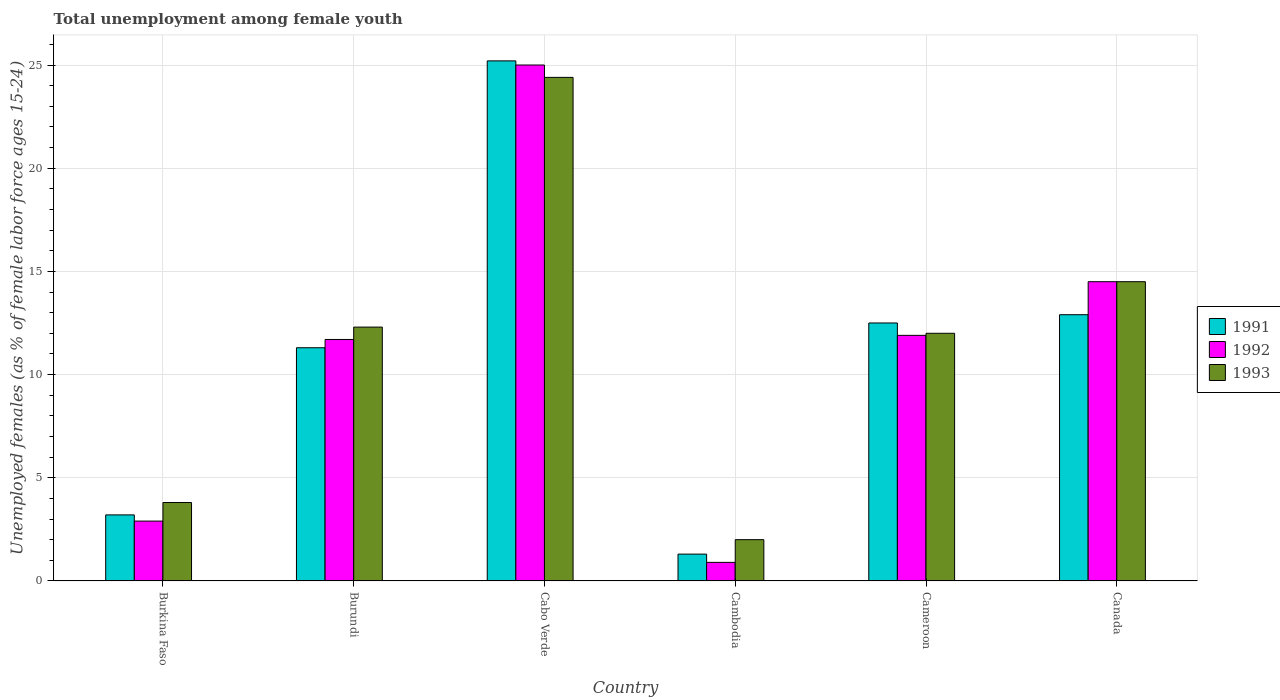Are the number of bars per tick equal to the number of legend labels?
Give a very brief answer. Yes. Are the number of bars on each tick of the X-axis equal?
Offer a very short reply. Yes. How many bars are there on the 2nd tick from the left?
Provide a short and direct response. 3. How many bars are there on the 3rd tick from the right?
Ensure brevity in your answer.  3. What is the label of the 3rd group of bars from the left?
Keep it short and to the point. Cabo Verde. In how many cases, is the number of bars for a given country not equal to the number of legend labels?
Offer a terse response. 0. What is the percentage of unemployed females in in 1992 in Cambodia?
Offer a terse response. 0.9. Across all countries, what is the maximum percentage of unemployed females in in 1993?
Make the answer very short. 24.4. In which country was the percentage of unemployed females in in 1991 maximum?
Keep it short and to the point. Cabo Verde. In which country was the percentage of unemployed females in in 1991 minimum?
Make the answer very short. Cambodia. What is the total percentage of unemployed females in in 1992 in the graph?
Ensure brevity in your answer.  66.9. What is the difference between the percentage of unemployed females in in 1993 in Cabo Verde and that in Canada?
Make the answer very short. 9.9. What is the difference between the percentage of unemployed females in in 1993 in Cabo Verde and the percentage of unemployed females in in 1992 in Burkina Faso?
Provide a succinct answer. 21.5. What is the average percentage of unemployed females in in 1991 per country?
Your answer should be compact. 11.07. What is the difference between the percentage of unemployed females in of/in 1992 and percentage of unemployed females in of/in 1993 in Burkina Faso?
Ensure brevity in your answer.  -0.9. What is the ratio of the percentage of unemployed females in in 1993 in Burkina Faso to that in Canada?
Your answer should be compact. 0.26. Is the percentage of unemployed females in in 1992 in Burundi less than that in Cameroon?
Make the answer very short. Yes. What is the difference between the highest and the second highest percentage of unemployed females in in 1991?
Keep it short and to the point. 12.3. What is the difference between the highest and the lowest percentage of unemployed females in in 1993?
Offer a very short reply. 22.4. Is the sum of the percentage of unemployed females in in 1991 in Burkina Faso and Cambodia greater than the maximum percentage of unemployed females in in 1993 across all countries?
Your answer should be very brief. No. What does the 2nd bar from the left in Cambodia represents?
Make the answer very short. 1992. Is it the case that in every country, the sum of the percentage of unemployed females in in 1992 and percentage of unemployed females in in 1991 is greater than the percentage of unemployed females in in 1993?
Your response must be concise. Yes. Are all the bars in the graph horizontal?
Offer a very short reply. No. Are the values on the major ticks of Y-axis written in scientific E-notation?
Make the answer very short. No. Does the graph contain any zero values?
Give a very brief answer. No. Where does the legend appear in the graph?
Provide a succinct answer. Center right. How many legend labels are there?
Offer a very short reply. 3. How are the legend labels stacked?
Provide a short and direct response. Vertical. What is the title of the graph?
Your answer should be compact. Total unemployment among female youth. Does "2012" appear as one of the legend labels in the graph?
Give a very brief answer. No. What is the label or title of the Y-axis?
Provide a short and direct response. Unemployed females (as % of female labor force ages 15-24). What is the Unemployed females (as % of female labor force ages 15-24) in 1991 in Burkina Faso?
Ensure brevity in your answer.  3.2. What is the Unemployed females (as % of female labor force ages 15-24) of 1992 in Burkina Faso?
Your response must be concise. 2.9. What is the Unemployed females (as % of female labor force ages 15-24) of 1993 in Burkina Faso?
Provide a short and direct response. 3.8. What is the Unemployed females (as % of female labor force ages 15-24) in 1991 in Burundi?
Make the answer very short. 11.3. What is the Unemployed females (as % of female labor force ages 15-24) in 1992 in Burundi?
Ensure brevity in your answer.  11.7. What is the Unemployed females (as % of female labor force ages 15-24) in 1993 in Burundi?
Provide a short and direct response. 12.3. What is the Unemployed females (as % of female labor force ages 15-24) in 1991 in Cabo Verde?
Your answer should be very brief. 25.2. What is the Unemployed females (as % of female labor force ages 15-24) of 1993 in Cabo Verde?
Your answer should be compact. 24.4. What is the Unemployed females (as % of female labor force ages 15-24) in 1991 in Cambodia?
Your response must be concise. 1.3. What is the Unemployed females (as % of female labor force ages 15-24) of 1992 in Cambodia?
Offer a very short reply. 0.9. What is the Unemployed females (as % of female labor force ages 15-24) in 1993 in Cambodia?
Make the answer very short. 2. What is the Unemployed females (as % of female labor force ages 15-24) of 1992 in Cameroon?
Your answer should be very brief. 11.9. What is the Unemployed females (as % of female labor force ages 15-24) of 1991 in Canada?
Provide a succinct answer. 12.9. What is the Unemployed females (as % of female labor force ages 15-24) in 1992 in Canada?
Provide a short and direct response. 14.5. What is the Unemployed females (as % of female labor force ages 15-24) in 1993 in Canada?
Offer a terse response. 14.5. Across all countries, what is the maximum Unemployed females (as % of female labor force ages 15-24) in 1991?
Provide a succinct answer. 25.2. Across all countries, what is the maximum Unemployed females (as % of female labor force ages 15-24) of 1992?
Your answer should be very brief. 25. Across all countries, what is the maximum Unemployed females (as % of female labor force ages 15-24) of 1993?
Provide a short and direct response. 24.4. Across all countries, what is the minimum Unemployed females (as % of female labor force ages 15-24) of 1991?
Offer a terse response. 1.3. Across all countries, what is the minimum Unemployed females (as % of female labor force ages 15-24) in 1992?
Offer a very short reply. 0.9. What is the total Unemployed females (as % of female labor force ages 15-24) of 1991 in the graph?
Give a very brief answer. 66.4. What is the total Unemployed females (as % of female labor force ages 15-24) in 1992 in the graph?
Provide a short and direct response. 66.9. What is the total Unemployed females (as % of female labor force ages 15-24) of 1993 in the graph?
Provide a succinct answer. 69. What is the difference between the Unemployed females (as % of female labor force ages 15-24) of 1993 in Burkina Faso and that in Burundi?
Your response must be concise. -8.5. What is the difference between the Unemployed females (as % of female labor force ages 15-24) of 1992 in Burkina Faso and that in Cabo Verde?
Provide a succinct answer. -22.1. What is the difference between the Unemployed females (as % of female labor force ages 15-24) in 1993 in Burkina Faso and that in Cabo Verde?
Offer a terse response. -20.6. What is the difference between the Unemployed females (as % of female labor force ages 15-24) of 1991 in Burkina Faso and that in Cambodia?
Offer a terse response. 1.9. What is the difference between the Unemployed females (as % of female labor force ages 15-24) in 1993 in Burkina Faso and that in Cambodia?
Your answer should be compact. 1.8. What is the difference between the Unemployed females (as % of female labor force ages 15-24) of 1991 in Burkina Faso and that in Cameroon?
Make the answer very short. -9.3. What is the difference between the Unemployed females (as % of female labor force ages 15-24) in 1991 in Burkina Faso and that in Canada?
Your answer should be very brief. -9.7. What is the difference between the Unemployed females (as % of female labor force ages 15-24) of 1993 in Burkina Faso and that in Canada?
Keep it short and to the point. -10.7. What is the difference between the Unemployed females (as % of female labor force ages 15-24) in 1991 in Burundi and that in Cabo Verde?
Provide a short and direct response. -13.9. What is the difference between the Unemployed females (as % of female labor force ages 15-24) of 1992 in Burundi and that in Cabo Verde?
Provide a short and direct response. -13.3. What is the difference between the Unemployed females (as % of female labor force ages 15-24) of 1993 in Burundi and that in Canada?
Offer a terse response. -2.2. What is the difference between the Unemployed females (as % of female labor force ages 15-24) in 1991 in Cabo Verde and that in Cambodia?
Your answer should be very brief. 23.9. What is the difference between the Unemployed females (as % of female labor force ages 15-24) of 1992 in Cabo Verde and that in Cambodia?
Ensure brevity in your answer.  24.1. What is the difference between the Unemployed females (as % of female labor force ages 15-24) of 1993 in Cabo Verde and that in Cambodia?
Keep it short and to the point. 22.4. What is the difference between the Unemployed females (as % of female labor force ages 15-24) of 1991 in Cabo Verde and that in Cameroon?
Offer a very short reply. 12.7. What is the difference between the Unemployed females (as % of female labor force ages 15-24) in 1991 in Cabo Verde and that in Canada?
Ensure brevity in your answer.  12.3. What is the difference between the Unemployed females (as % of female labor force ages 15-24) in 1992 in Cabo Verde and that in Canada?
Offer a very short reply. 10.5. What is the difference between the Unemployed females (as % of female labor force ages 15-24) in 1991 in Cambodia and that in Cameroon?
Give a very brief answer. -11.2. What is the difference between the Unemployed females (as % of female labor force ages 15-24) of 1992 in Cambodia and that in Cameroon?
Your answer should be compact. -11. What is the difference between the Unemployed females (as % of female labor force ages 15-24) of 1991 in Cambodia and that in Canada?
Offer a very short reply. -11.6. What is the difference between the Unemployed females (as % of female labor force ages 15-24) in 1992 in Cambodia and that in Canada?
Give a very brief answer. -13.6. What is the difference between the Unemployed females (as % of female labor force ages 15-24) of 1993 in Cambodia and that in Canada?
Keep it short and to the point. -12.5. What is the difference between the Unemployed females (as % of female labor force ages 15-24) of 1991 in Cameroon and that in Canada?
Make the answer very short. -0.4. What is the difference between the Unemployed females (as % of female labor force ages 15-24) of 1992 in Cameroon and that in Canada?
Keep it short and to the point. -2.6. What is the difference between the Unemployed females (as % of female labor force ages 15-24) of 1993 in Cameroon and that in Canada?
Your response must be concise. -2.5. What is the difference between the Unemployed females (as % of female labor force ages 15-24) in 1991 in Burkina Faso and the Unemployed females (as % of female labor force ages 15-24) in 1992 in Burundi?
Your answer should be compact. -8.5. What is the difference between the Unemployed females (as % of female labor force ages 15-24) of 1991 in Burkina Faso and the Unemployed females (as % of female labor force ages 15-24) of 1992 in Cabo Verde?
Keep it short and to the point. -21.8. What is the difference between the Unemployed females (as % of female labor force ages 15-24) in 1991 in Burkina Faso and the Unemployed females (as % of female labor force ages 15-24) in 1993 in Cabo Verde?
Keep it short and to the point. -21.2. What is the difference between the Unemployed females (as % of female labor force ages 15-24) of 1992 in Burkina Faso and the Unemployed females (as % of female labor force ages 15-24) of 1993 in Cabo Verde?
Your answer should be very brief. -21.5. What is the difference between the Unemployed females (as % of female labor force ages 15-24) in 1991 in Burkina Faso and the Unemployed females (as % of female labor force ages 15-24) in 1992 in Cambodia?
Provide a succinct answer. 2.3. What is the difference between the Unemployed females (as % of female labor force ages 15-24) of 1991 in Burkina Faso and the Unemployed females (as % of female labor force ages 15-24) of 1993 in Cambodia?
Ensure brevity in your answer.  1.2. What is the difference between the Unemployed females (as % of female labor force ages 15-24) of 1991 in Burkina Faso and the Unemployed females (as % of female labor force ages 15-24) of 1993 in Cameroon?
Your response must be concise. -8.8. What is the difference between the Unemployed females (as % of female labor force ages 15-24) in 1991 in Burkina Faso and the Unemployed females (as % of female labor force ages 15-24) in 1992 in Canada?
Make the answer very short. -11.3. What is the difference between the Unemployed females (as % of female labor force ages 15-24) in 1991 in Burkina Faso and the Unemployed females (as % of female labor force ages 15-24) in 1993 in Canada?
Your answer should be compact. -11.3. What is the difference between the Unemployed females (as % of female labor force ages 15-24) in 1991 in Burundi and the Unemployed females (as % of female labor force ages 15-24) in 1992 in Cabo Verde?
Provide a short and direct response. -13.7. What is the difference between the Unemployed females (as % of female labor force ages 15-24) in 1991 in Burundi and the Unemployed females (as % of female labor force ages 15-24) in 1993 in Cabo Verde?
Keep it short and to the point. -13.1. What is the difference between the Unemployed females (as % of female labor force ages 15-24) in 1992 in Burundi and the Unemployed females (as % of female labor force ages 15-24) in 1993 in Cabo Verde?
Provide a short and direct response. -12.7. What is the difference between the Unemployed females (as % of female labor force ages 15-24) of 1991 in Burundi and the Unemployed females (as % of female labor force ages 15-24) of 1992 in Cambodia?
Keep it short and to the point. 10.4. What is the difference between the Unemployed females (as % of female labor force ages 15-24) of 1992 in Burundi and the Unemployed females (as % of female labor force ages 15-24) of 1993 in Cambodia?
Your response must be concise. 9.7. What is the difference between the Unemployed females (as % of female labor force ages 15-24) in 1991 in Burundi and the Unemployed females (as % of female labor force ages 15-24) in 1993 in Cameroon?
Offer a terse response. -0.7. What is the difference between the Unemployed females (as % of female labor force ages 15-24) in 1991 in Burundi and the Unemployed females (as % of female labor force ages 15-24) in 1992 in Canada?
Your answer should be compact. -3.2. What is the difference between the Unemployed females (as % of female labor force ages 15-24) of 1991 in Burundi and the Unemployed females (as % of female labor force ages 15-24) of 1993 in Canada?
Offer a very short reply. -3.2. What is the difference between the Unemployed females (as % of female labor force ages 15-24) in 1991 in Cabo Verde and the Unemployed females (as % of female labor force ages 15-24) in 1992 in Cambodia?
Your answer should be very brief. 24.3. What is the difference between the Unemployed females (as % of female labor force ages 15-24) in 1991 in Cabo Verde and the Unemployed females (as % of female labor force ages 15-24) in 1993 in Cambodia?
Your response must be concise. 23.2. What is the difference between the Unemployed females (as % of female labor force ages 15-24) of 1992 in Cabo Verde and the Unemployed females (as % of female labor force ages 15-24) of 1993 in Cambodia?
Provide a short and direct response. 23. What is the difference between the Unemployed females (as % of female labor force ages 15-24) of 1991 in Cabo Verde and the Unemployed females (as % of female labor force ages 15-24) of 1993 in Cameroon?
Offer a very short reply. 13.2. What is the difference between the Unemployed females (as % of female labor force ages 15-24) of 1992 in Cabo Verde and the Unemployed females (as % of female labor force ages 15-24) of 1993 in Cameroon?
Give a very brief answer. 13. What is the difference between the Unemployed females (as % of female labor force ages 15-24) in 1991 in Cabo Verde and the Unemployed females (as % of female labor force ages 15-24) in 1992 in Canada?
Ensure brevity in your answer.  10.7. What is the difference between the Unemployed females (as % of female labor force ages 15-24) of 1991 in Cambodia and the Unemployed females (as % of female labor force ages 15-24) of 1992 in Canada?
Ensure brevity in your answer.  -13.2. What is the difference between the Unemployed females (as % of female labor force ages 15-24) in 1992 in Cambodia and the Unemployed females (as % of female labor force ages 15-24) in 1993 in Canada?
Your response must be concise. -13.6. What is the difference between the Unemployed females (as % of female labor force ages 15-24) of 1991 in Cameroon and the Unemployed females (as % of female labor force ages 15-24) of 1993 in Canada?
Give a very brief answer. -2. What is the difference between the Unemployed females (as % of female labor force ages 15-24) in 1992 in Cameroon and the Unemployed females (as % of female labor force ages 15-24) in 1993 in Canada?
Your response must be concise. -2.6. What is the average Unemployed females (as % of female labor force ages 15-24) of 1991 per country?
Your response must be concise. 11.07. What is the average Unemployed females (as % of female labor force ages 15-24) of 1992 per country?
Your answer should be very brief. 11.15. What is the difference between the Unemployed females (as % of female labor force ages 15-24) of 1991 and Unemployed females (as % of female labor force ages 15-24) of 1992 in Burkina Faso?
Your response must be concise. 0.3. What is the difference between the Unemployed females (as % of female labor force ages 15-24) of 1991 and Unemployed females (as % of female labor force ages 15-24) of 1993 in Burkina Faso?
Your response must be concise. -0.6. What is the difference between the Unemployed females (as % of female labor force ages 15-24) in 1992 and Unemployed females (as % of female labor force ages 15-24) in 1993 in Burkina Faso?
Keep it short and to the point. -0.9. What is the difference between the Unemployed females (as % of female labor force ages 15-24) in 1991 and Unemployed females (as % of female labor force ages 15-24) in 1992 in Burundi?
Provide a short and direct response. -0.4. What is the difference between the Unemployed females (as % of female labor force ages 15-24) in 1991 and Unemployed females (as % of female labor force ages 15-24) in 1993 in Burundi?
Give a very brief answer. -1. What is the difference between the Unemployed females (as % of female labor force ages 15-24) of 1992 and Unemployed females (as % of female labor force ages 15-24) of 1993 in Burundi?
Provide a succinct answer. -0.6. What is the difference between the Unemployed females (as % of female labor force ages 15-24) of 1991 and Unemployed females (as % of female labor force ages 15-24) of 1992 in Cabo Verde?
Offer a very short reply. 0.2. What is the difference between the Unemployed females (as % of female labor force ages 15-24) in 1991 and Unemployed females (as % of female labor force ages 15-24) in 1992 in Cambodia?
Keep it short and to the point. 0.4. What is the difference between the Unemployed females (as % of female labor force ages 15-24) in 1991 and Unemployed females (as % of female labor force ages 15-24) in 1993 in Cambodia?
Offer a very short reply. -0.7. What is the difference between the Unemployed females (as % of female labor force ages 15-24) of 1991 and Unemployed females (as % of female labor force ages 15-24) of 1993 in Cameroon?
Make the answer very short. 0.5. What is the difference between the Unemployed females (as % of female labor force ages 15-24) in 1992 and Unemployed females (as % of female labor force ages 15-24) in 1993 in Cameroon?
Your answer should be compact. -0.1. What is the difference between the Unemployed females (as % of female labor force ages 15-24) in 1991 and Unemployed females (as % of female labor force ages 15-24) in 1993 in Canada?
Offer a terse response. -1.6. What is the difference between the Unemployed females (as % of female labor force ages 15-24) in 1992 and Unemployed females (as % of female labor force ages 15-24) in 1993 in Canada?
Your answer should be compact. 0. What is the ratio of the Unemployed females (as % of female labor force ages 15-24) of 1991 in Burkina Faso to that in Burundi?
Offer a very short reply. 0.28. What is the ratio of the Unemployed females (as % of female labor force ages 15-24) of 1992 in Burkina Faso to that in Burundi?
Provide a short and direct response. 0.25. What is the ratio of the Unemployed females (as % of female labor force ages 15-24) of 1993 in Burkina Faso to that in Burundi?
Provide a short and direct response. 0.31. What is the ratio of the Unemployed females (as % of female labor force ages 15-24) of 1991 in Burkina Faso to that in Cabo Verde?
Make the answer very short. 0.13. What is the ratio of the Unemployed females (as % of female labor force ages 15-24) of 1992 in Burkina Faso to that in Cabo Verde?
Offer a terse response. 0.12. What is the ratio of the Unemployed females (as % of female labor force ages 15-24) of 1993 in Burkina Faso to that in Cabo Verde?
Make the answer very short. 0.16. What is the ratio of the Unemployed females (as % of female labor force ages 15-24) of 1991 in Burkina Faso to that in Cambodia?
Your answer should be very brief. 2.46. What is the ratio of the Unemployed females (as % of female labor force ages 15-24) in 1992 in Burkina Faso to that in Cambodia?
Your answer should be compact. 3.22. What is the ratio of the Unemployed females (as % of female labor force ages 15-24) in 1993 in Burkina Faso to that in Cambodia?
Provide a succinct answer. 1.9. What is the ratio of the Unemployed females (as % of female labor force ages 15-24) of 1991 in Burkina Faso to that in Cameroon?
Ensure brevity in your answer.  0.26. What is the ratio of the Unemployed females (as % of female labor force ages 15-24) of 1992 in Burkina Faso to that in Cameroon?
Ensure brevity in your answer.  0.24. What is the ratio of the Unemployed females (as % of female labor force ages 15-24) of 1993 in Burkina Faso to that in Cameroon?
Keep it short and to the point. 0.32. What is the ratio of the Unemployed females (as % of female labor force ages 15-24) of 1991 in Burkina Faso to that in Canada?
Keep it short and to the point. 0.25. What is the ratio of the Unemployed females (as % of female labor force ages 15-24) of 1993 in Burkina Faso to that in Canada?
Your answer should be compact. 0.26. What is the ratio of the Unemployed females (as % of female labor force ages 15-24) in 1991 in Burundi to that in Cabo Verde?
Ensure brevity in your answer.  0.45. What is the ratio of the Unemployed females (as % of female labor force ages 15-24) in 1992 in Burundi to that in Cabo Verde?
Provide a succinct answer. 0.47. What is the ratio of the Unemployed females (as % of female labor force ages 15-24) in 1993 in Burundi to that in Cabo Verde?
Your answer should be very brief. 0.5. What is the ratio of the Unemployed females (as % of female labor force ages 15-24) in 1991 in Burundi to that in Cambodia?
Provide a succinct answer. 8.69. What is the ratio of the Unemployed females (as % of female labor force ages 15-24) in 1992 in Burundi to that in Cambodia?
Provide a short and direct response. 13. What is the ratio of the Unemployed females (as % of female labor force ages 15-24) in 1993 in Burundi to that in Cambodia?
Provide a succinct answer. 6.15. What is the ratio of the Unemployed females (as % of female labor force ages 15-24) in 1991 in Burundi to that in Cameroon?
Provide a short and direct response. 0.9. What is the ratio of the Unemployed females (as % of female labor force ages 15-24) in 1992 in Burundi to that in Cameroon?
Your response must be concise. 0.98. What is the ratio of the Unemployed females (as % of female labor force ages 15-24) in 1991 in Burundi to that in Canada?
Provide a short and direct response. 0.88. What is the ratio of the Unemployed females (as % of female labor force ages 15-24) in 1992 in Burundi to that in Canada?
Offer a very short reply. 0.81. What is the ratio of the Unemployed females (as % of female labor force ages 15-24) of 1993 in Burundi to that in Canada?
Give a very brief answer. 0.85. What is the ratio of the Unemployed females (as % of female labor force ages 15-24) in 1991 in Cabo Verde to that in Cambodia?
Keep it short and to the point. 19.38. What is the ratio of the Unemployed females (as % of female labor force ages 15-24) of 1992 in Cabo Verde to that in Cambodia?
Ensure brevity in your answer.  27.78. What is the ratio of the Unemployed females (as % of female labor force ages 15-24) of 1991 in Cabo Verde to that in Cameroon?
Provide a succinct answer. 2.02. What is the ratio of the Unemployed females (as % of female labor force ages 15-24) of 1992 in Cabo Verde to that in Cameroon?
Give a very brief answer. 2.1. What is the ratio of the Unemployed females (as % of female labor force ages 15-24) in 1993 in Cabo Verde to that in Cameroon?
Your answer should be very brief. 2.03. What is the ratio of the Unemployed females (as % of female labor force ages 15-24) of 1991 in Cabo Verde to that in Canada?
Provide a short and direct response. 1.95. What is the ratio of the Unemployed females (as % of female labor force ages 15-24) in 1992 in Cabo Verde to that in Canada?
Provide a short and direct response. 1.72. What is the ratio of the Unemployed females (as % of female labor force ages 15-24) of 1993 in Cabo Verde to that in Canada?
Offer a very short reply. 1.68. What is the ratio of the Unemployed females (as % of female labor force ages 15-24) of 1991 in Cambodia to that in Cameroon?
Your answer should be very brief. 0.1. What is the ratio of the Unemployed females (as % of female labor force ages 15-24) in 1992 in Cambodia to that in Cameroon?
Ensure brevity in your answer.  0.08. What is the ratio of the Unemployed females (as % of female labor force ages 15-24) in 1991 in Cambodia to that in Canada?
Make the answer very short. 0.1. What is the ratio of the Unemployed females (as % of female labor force ages 15-24) in 1992 in Cambodia to that in Canada?
Your answer should be compact. 0.06. What is the ratio of the Unemployed females (as % of female labor force ages 15-24) in 1993 in Cambodia to that in Canada?
Offer a terse response. 0.14. What is the ratio of the Unemployed females (as % of female labor force ages 15-24) in 1991 in Cameroon to that in Canada?
Your answer should be compact. 0.97. What is the ratio of the Unemployed females (as % of female labor force ages 15-24) of 1992 in Cameroon to that in Canada?
Give a very brief answer. 0.82. What is the ratio of the Unemployed females (as % of female labor force ages 15-24) of 1993 in Cameroon to that in Canada?
Provide a short and direct response. 0.83. What is the difference between the highest and the second highest Unemployed females (as % of female labor force ages 15-24) of 1992?
Your response must be concise. 10.5. What is the difference between the highest and the second highest Unemployed females (as % of female labor force ages 15-24) of 1993?
Keep it short and to the point. 9.9. What is the difference between the highest and the lowest Unemployed females (as % of female labor force ages 15-24) in 1991?
Offer a terse response. 23.9. What is the difference between the highest and the lowest Unemployed females (as % of female labor force ages 15-24) in 1992?
Give a very brief answer. 24.1. What is the difference between the highest and the lowest Unemployed females (as % of female labor force ages 15-24) in 1993?
Give a very brief answer. 22.4. 